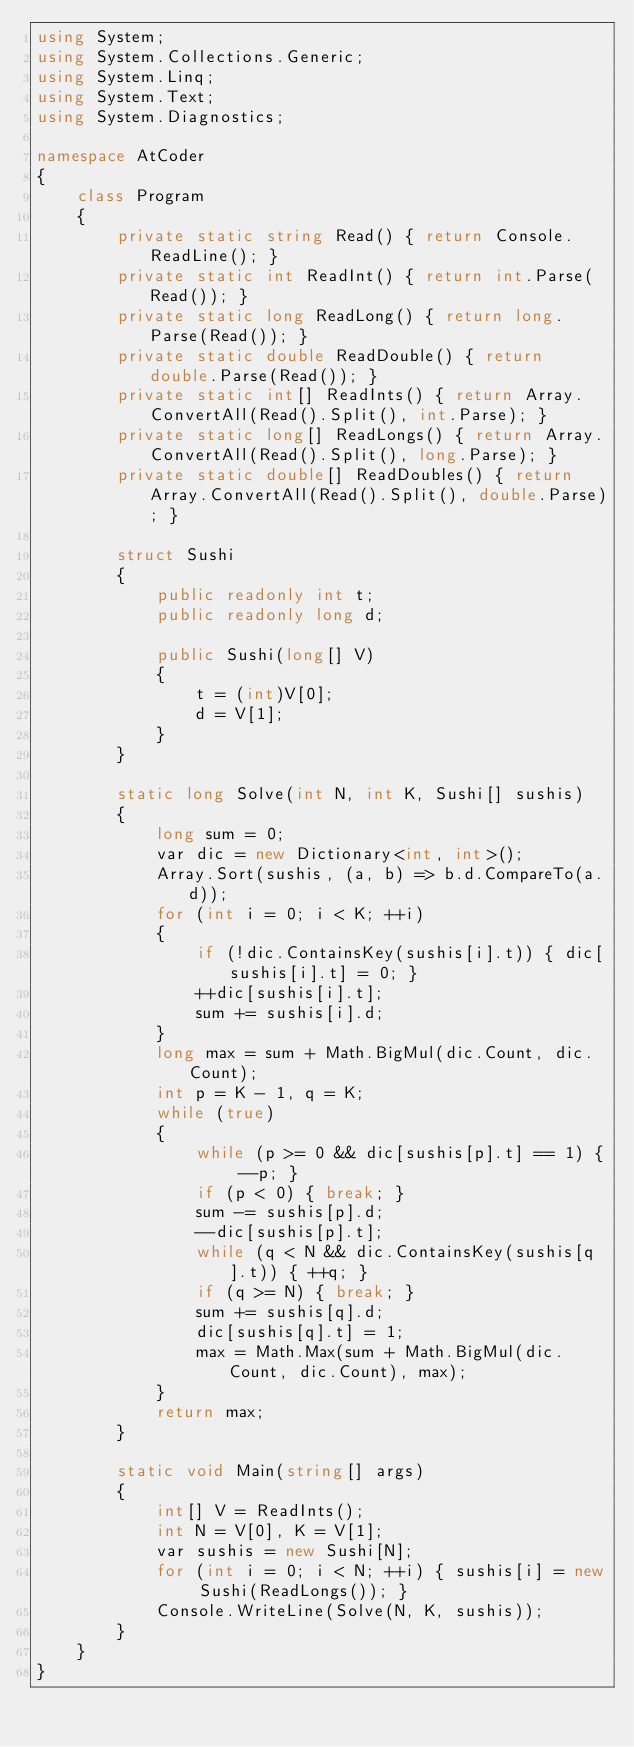<code> <loc_0><loc_0><loc_500><loc_500><_C#_>using System;
using System.Collections.Generic;
using System.Linq;
using System.Text;
using System.Diagnostics;

namespace AtCoder
{
    class Program
    {
        private static string Read() { return Console.ReadLine(); }
        private static int ReadInt() { return int.Parse(Read()); }
        private static long ReadLong() { return long.Parse(Read()); }
        private static double ReadDouble() { return double.Parse(Read()); }
        private static int[] ReadInts() { return Array.ConvertAll(Read().Split(), int.Parse); }
        private static long[] ReadLongs() { return Array.ConvertAll(Read().Split(), long.Parse); }
        private static double[] ReadDoubles() { return Array.ConvertAll(Read().Split(), double.Parse); }

        struct Sushi
        {
            public readonly int t;
            public readonly long d;

            public Sushi(long[] V)
            {
                t = (int)V[0];
                d = V[1];
            }
        }

        static long Solve(int N, int K, Sushi[] sushis)
        {
            long sum = 0;
            var dic = new Dictionary<int, int>();
            Array.Sort(sushis, (a, b) => b.d.CompareTo(a.d));
            for (int i = 0; i < K; ++i)
            {
                if (!dic.ContainsKey(sushis[i].t)) { dic[sushis[i].t] = 0; }
                ++dic[sushis[i].t];
                sum += sushis[i].d;
            }
            long max = sum + Math.BigMul(dic.Count, dic.Count);
            int p = K - 1, q = K;
            while (true)
            {
                while (p >= 0 && dic[sushis[p].t] == 1) { --p; }
                if (p < 0) { break; }
                sum -= sushis[p].d;
                --dic[sushis[p].t];
                while (q < N && dic.ContainsKey(sushis[q].t)) { ++q; }
                if (q >= N) { break; }
                sum += sushis[q].d;
                dic[sushis[q].t] = 1;
                max = Math.Max(sum + Math.BigMul(dic.Count, dic.Count), max);
            }
            return max;
        }

        static void Main(string[] args)
        {
            int[] V = ReadInts();
            int N = V[0], K = V[1];
            var sushis = new Sushi[N];
            for (int i = 0; i < N; ++i) { sushis[i] = new Sushi(ReadLongs()); }
            Console.WriteLine(Solve(N, K, sushis));
        }
    }
}
</code> 